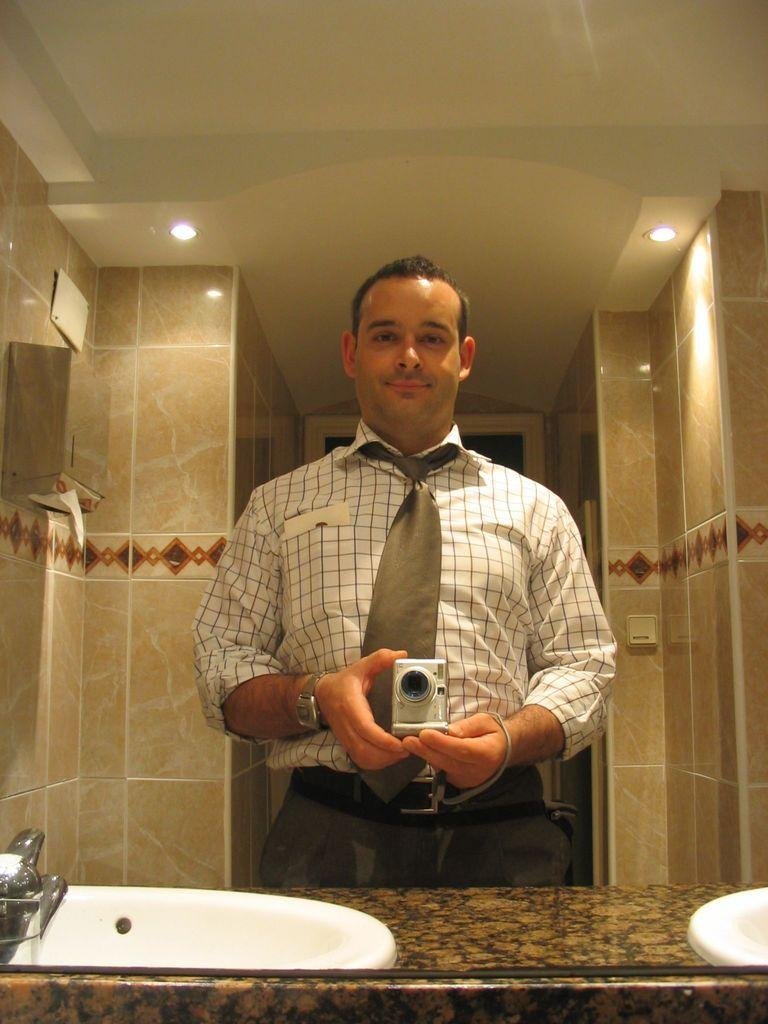What type of fixture is present in the image? There is a sink in the image. What is attached to the sink? There is a tap in the image. What type of surface is visible in the image? There are tiles in the image. Who is present in the image? There is a man in the image. What is the man holding in his hands? The man is holding a camera in his hands. Where is the pail located in the image? There is no pail present in the image. What type of dish is the man holding in his hands? The man is not holding a plate in his hands; he is holding a camera. 